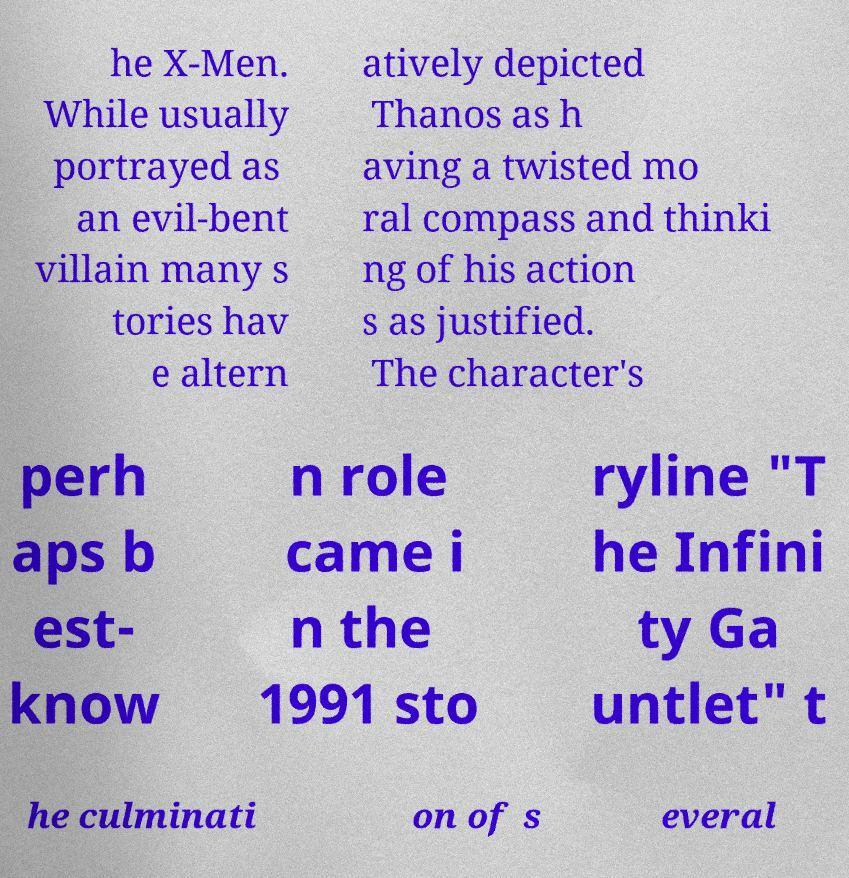For documentation purposes, I need the text within this image transcribed. Could you provide that? he X-Men. While usually portrayed as an evil-bent villain many s tories hav e altern atively depicted Thanos as h aving a twisted mo ral compass and thinki ng of his action s as justified. The character's perh aps b est- know n role came i n the 1991 sto ryline "T he Infini ty Ga untlet" t he culminati on of s everal 